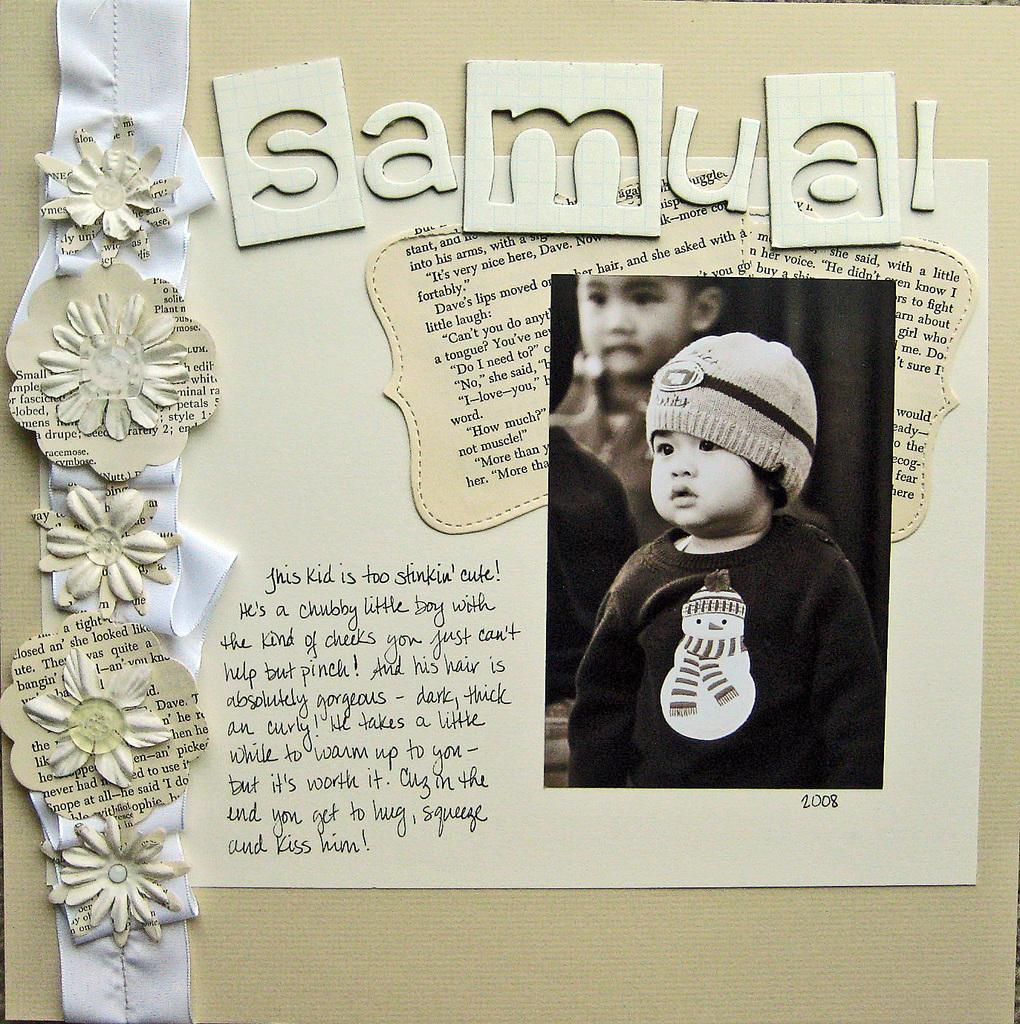Please provide a concise description of this image. In this picture, we can see a paper and on the paper it is written something, a baby photo is pasted and some decorative items. 